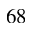Convert formula to latex. <formula><loc_0><loc_0><loc_500><loc_500>^ { 6 } 8</formula> 